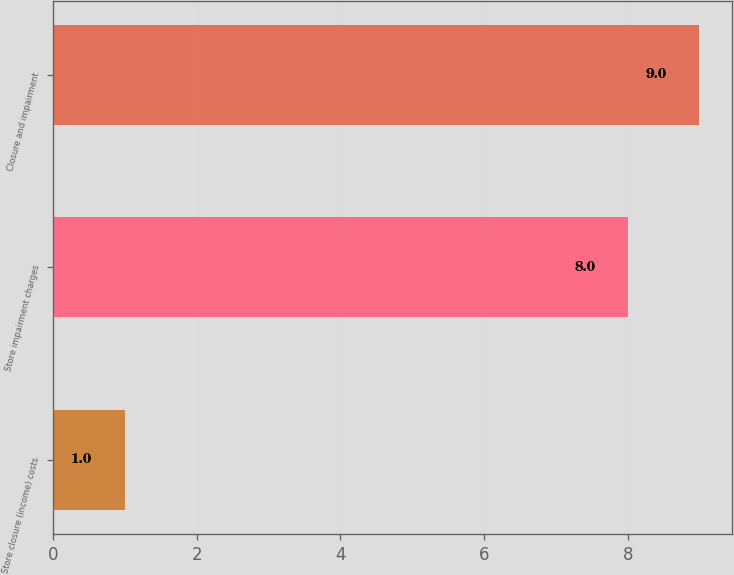Convert chart to OTSL. <chart><loc_0><loc_0><loc_500><loc_500><bar_chart><fcel>Store closure (income) costs<fcel>Store impairment charges<fcel>Closure and impairment<nl><fcel>1<fcel>8<fcel>9<nl></chart> 